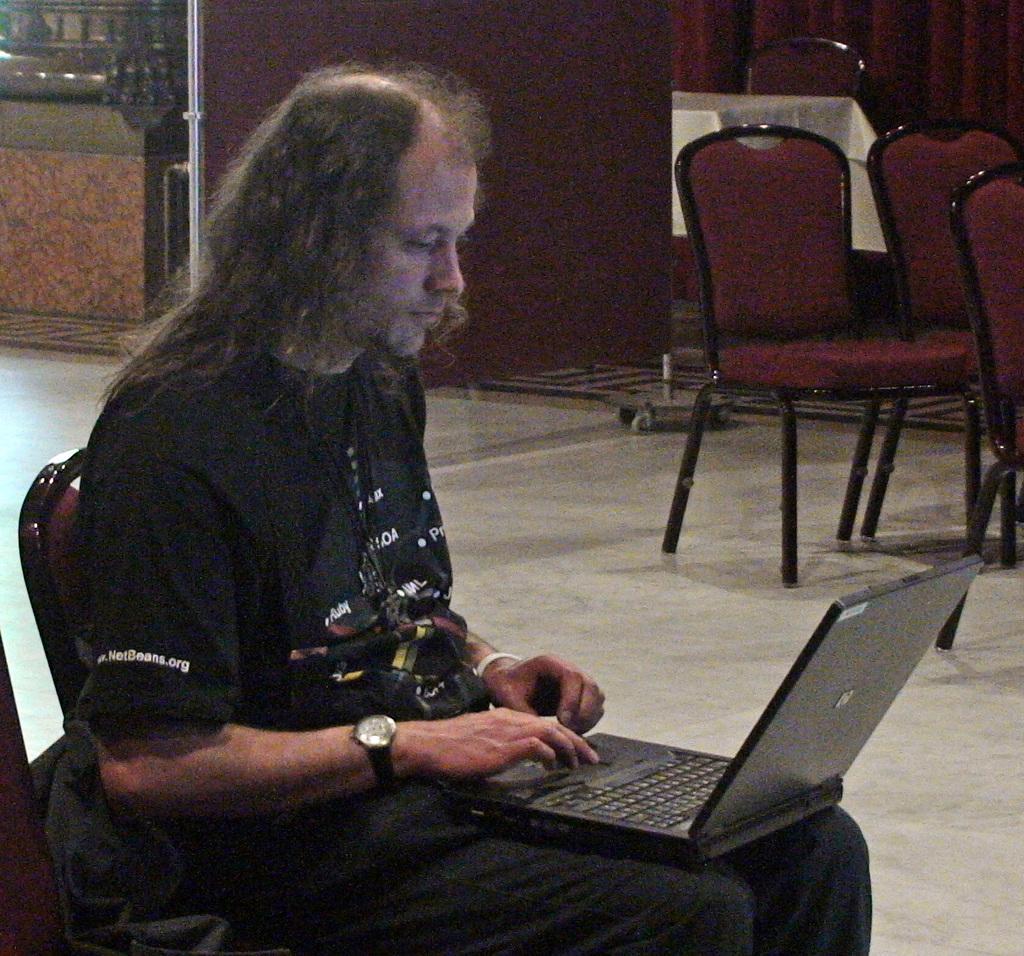In one or two sentences, can you explain what this image depicts? In the picture we can see a man sitting on a chair, he is with black T-shirt and doing some work on the laptop and beside him we can see some chairs on the floor and behind it, we can see a curtain which is red in color and beside it we can see a table. 